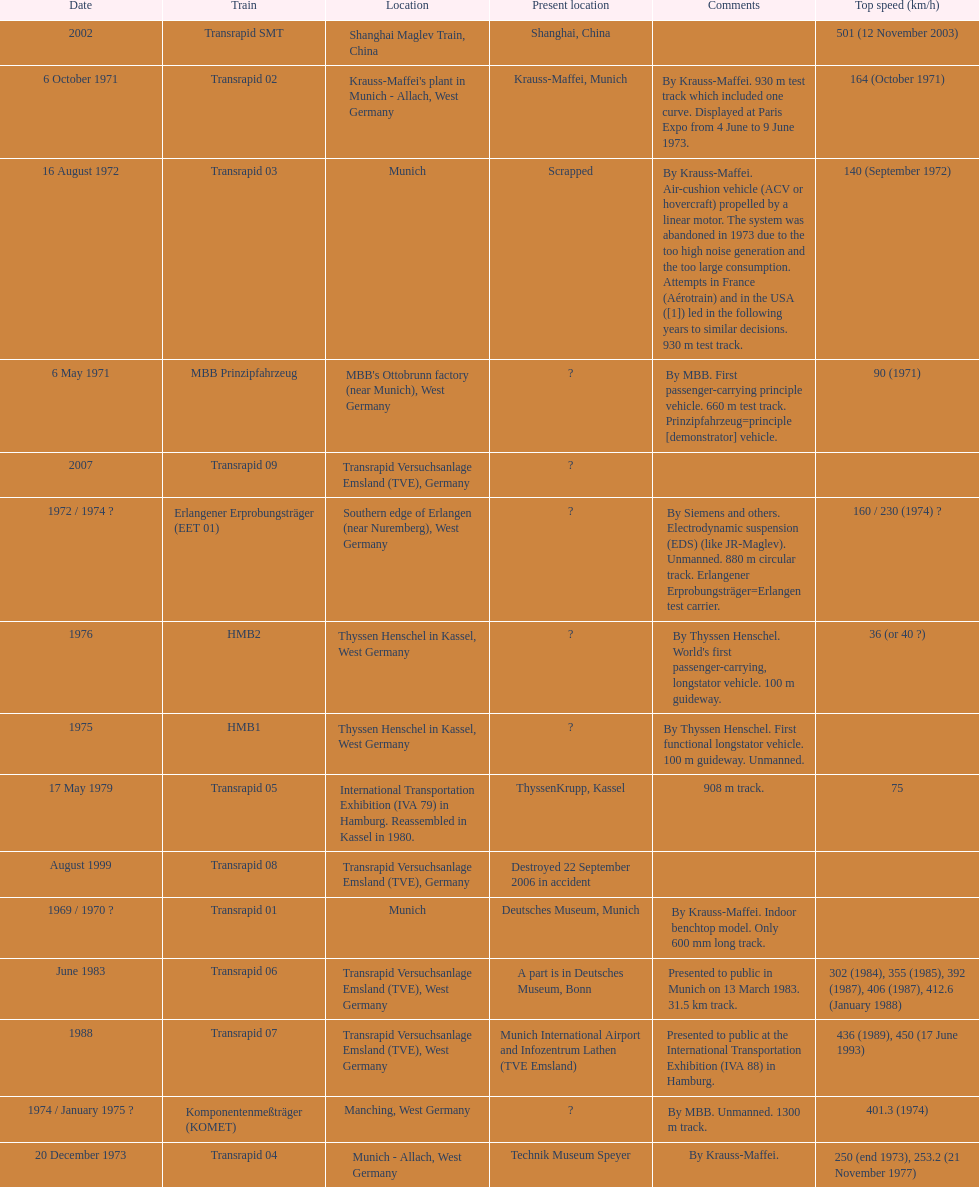What train was developed after the erlangener erprobungstrager? Transrapid 04. 